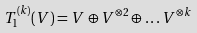Convert formula to latex. <formula><loc_0><loc_0><loc_500><loc_500>T _ { 1 } ^ { ( k ) } ( V ) = V \oplus V ^ { \otimes 2 } \oplus \dots V ^ { \otimes k }</formula> 